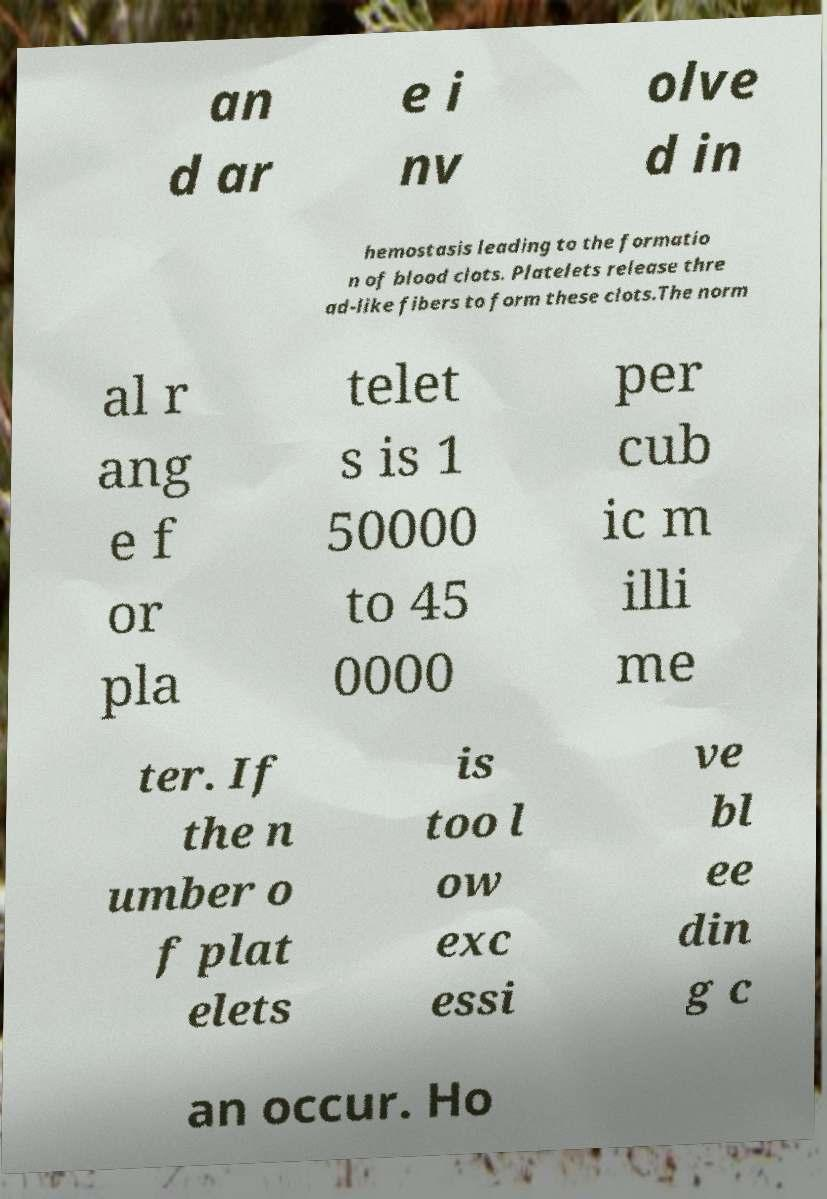There's text embedded in this image that I need extracted. Can you transcribe it verbatim? an d ar e i nv olve d in hemostasis leading to the formatio n of blood clots. Platelets release thre ad-like fibers to form these clots.The norm al r ang e f or pla telet s is 1 50000 to 45 0000 per cub ic m illi me ter. If the n umber o f plat elets is too l ow exc essi ve bl ee din g c an occur. Ho 